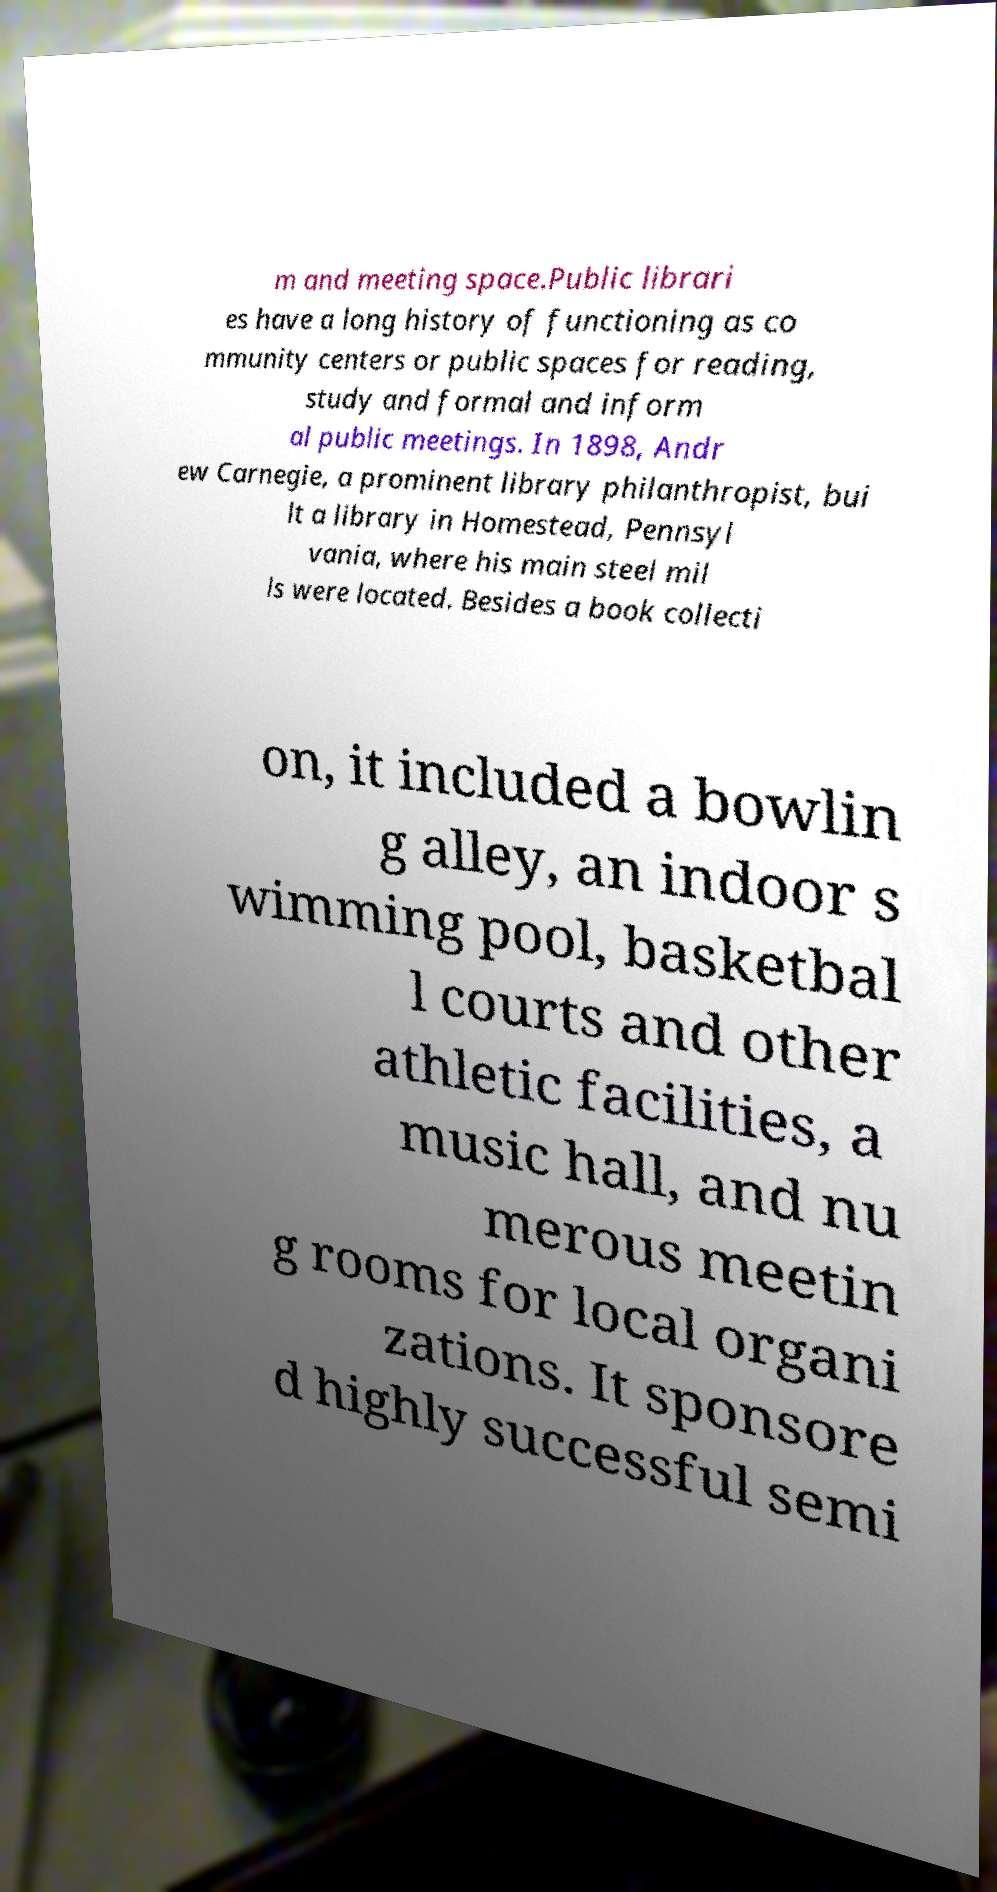Please read and relay the text visible in this image. What does it say? m and meeting space.Public librari es have a long history of functioning as co mmunity centers or public spaces for reading, study and formal and inform al public meetings. In 1898, Andr ew Carnegie, a prominent library philanthropist, bui lt a library in Homestead, Pennsyl vania, where his main steel mil ls were located. Besides a book collecti on, it included a bowlin g alley, an indoor s wimming pool, basketbal l courts and other athletic facilities, a music hall, and nu merous meetin g rooms for local organi zations. It sponsore d highly successful semi 